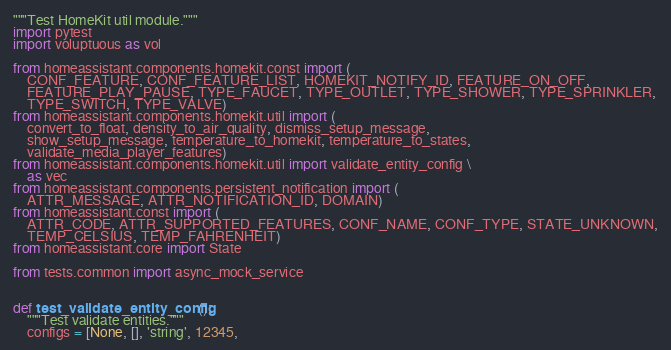Convert code to text. <code><loc_0><loc_0><loc_500><loc_500><_Python_>"""Test HomeKit util module."""
import pytest
import voluptuous as vol

from homeassistant.components.homekit.const import (
    CONF_FEATURE, CONF_FEATURE_LIST, HOMEKIT_NOTIFY_ID, FEATURE_ON_OFF,
    FEATURE_PLAY_PAUSE, TYPE_FAUCET, TYPE_OUTLET, TYPE_SHOWER, TYPE_SPRINKLER,
    TYPE_SWITCH, TYPE_VALVE)
from homeassistant.components.homekit.util import (
    convert_to_float, density_to_air_quality, dismiss_setup_message,
    show_setup_message, temperature_to_homekit, temperature_to_states,
    validate_media_player_features)
from homeassistant.components.homekit.util import validate_entity_config \
    as vec
from homeassistant.components.persistent_notification import (
    ATTR_MESSAGE, ATTR_NOTIFICATION_ID, DOMAIN)
from homeassistant.const import (
    ATTR_CODE, ATTR_SUPPORTED_FEATURES, CONF_NAME, CONF_TYPE, STATE_UNKNOWN,
    TEMP_CELSIUS, TEMP_FAHRENHEIT)
from homeassistant.core import State

from tests.common import async_mock_service


def test_validate_entity_config():
    """Test validate entities."""
    configs = [None, [], 'string', 12345,</code> 